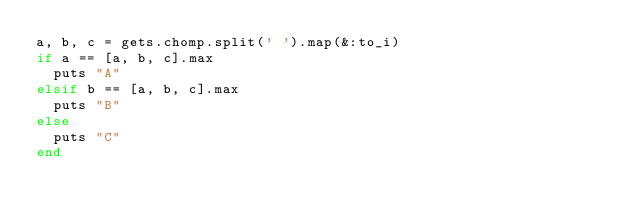Convert code to text. <code><loc_0><loc_0><loc_500><loc_500><_Ruby_>a, b, c = gets.chomp.split(' ').map(&:to_i)
if a == [a, b, c].max
	puts "A"
elsif b == [a, b, c].max
	puts "B"
else
	puts "C"
end
</code> 